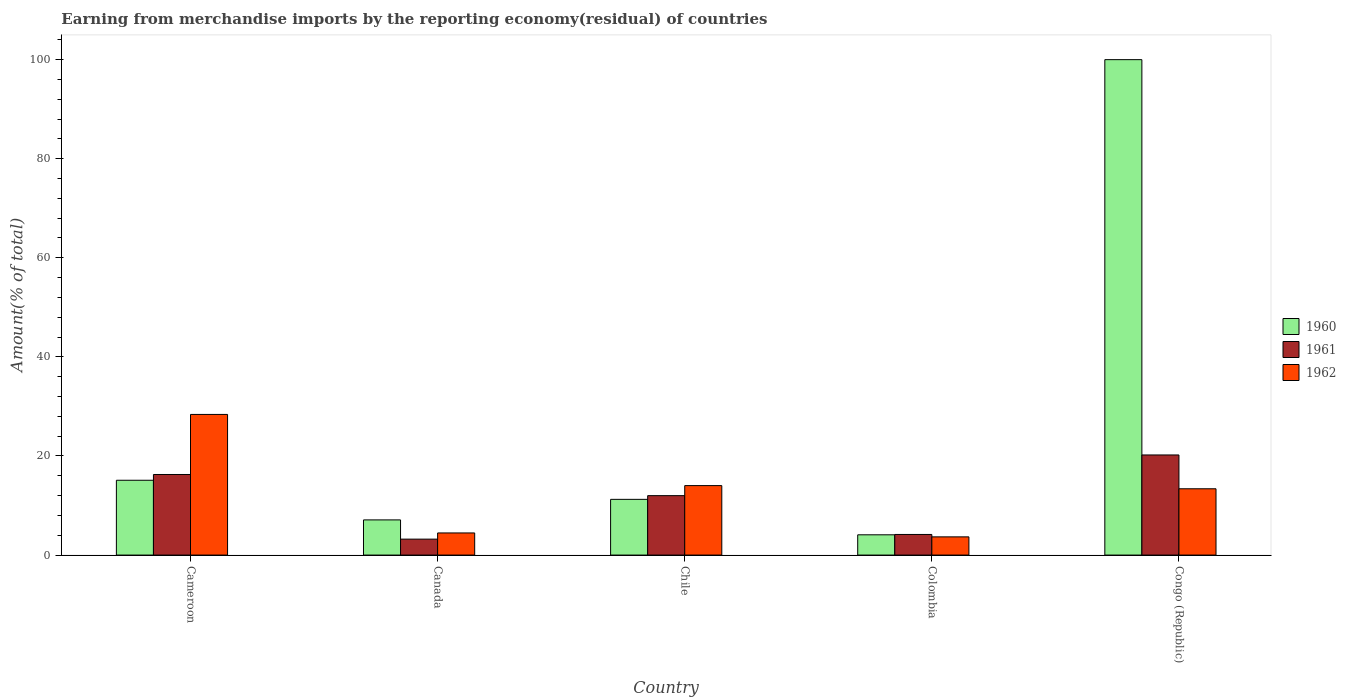What is the label of the 1st group of bars from the left?
Provide a short and direct response. Cameroon. What is the percentage of amount earned from merchandise imports in 1962 in Canada?
Make the answer very short. 4.47. Across all countries, what is the maximum percentage of amount earned from merchandise imports in 1960?
Offer a very short reply. 100. Across all countries, what is the minimum percentage of amount earned from merchandise imports in 1962?
Ensure brevity in your answer.  3.68. In which country was the percentage of amount earned from merchandise imports in 1962 maximum?
Your answer should be compact. Cameroon. In which country was the percentage of amount earned from merchandise imports in 1961 minimum?
Your response must be concise. Canada. What is the total percentage of amount earned from merchandise imports in 1962 in the graph?
Provide a short and direct response. 63.94. What is the difference between the percentage of amount earned from merchandise imports in 1961 in Cameroon and that in Congo (Republic)?
Provide a succinct answer. -3.94. What is the difference between the percentage of amount earned from merchandise imports in 1961 in Colombia and the percentage of amount earned from merchandise imports in 1960 in Canada?
Make the answer very short. -2.94. What is the average percentage of amount earned from merchandise imports in 1960 per country?
Offer a terse response. 27.51. What is the difference between the percentage of amount earned from merchandise imports of/in 1962 and percentage of amount earned from merchandise imports of/in 1961 in Canada?
Keep it short and to the point. 1.25. In how many countries, is the percentage of amount earned from merchandise imports in 1962 greater than 68 %?
Offer a very short reply. 0. What is the ratio of the percentage of amount earned from merchandise imports in 1961 in Canada to that in Colombia?
Offer a very short reply. 0.77. Is the percentage of amount earned from merchandise imports in 1961 in Colombia less than that in Congo (Republic)?
Offer a terse response. Yes. Is the difference between the percentage of amount earned from merchandise imports in 1962 in Canada and Chile greater than the difference between the percentage of amount earned from merchandise imports in 1961 in Canada and Chile?
Make the answer very short. No. What is the difference between the highest and the second highest percentage of amount earned from merchandise imports in 1960?
Provide a succinct answer. -88.75. What is the difference between the highest and the lowest percentage of amount earned from merchandise imports in 1960?
Your response must be concise. 95.91. What does the 1st bar from the right in Colombia represents?
Provide a succinct answer. 1962. Is it the case that in every country, the sum of the percentage of amount earned from merchandise imports in 1961 and percentage of amount earned from merchandise imports in 1960 is greater than the percentage of amount earned from merchandise imports in 1962?
Your response must be concise. Yes. Are all the bars in the graph horizontal?
Give a very brief answer. No. How many countries are there in the graph?
Provide a succinct answer. 5. What is the difference between two consecutive major ticks on the Y-axis?
Give a very brief answer. 20. Are the values on the major ticks of Y-axis written in scientific E-notation?
Offer a terse response. No. How many legend labels are there?
Give a very brief answer. 3. What is the title of the graph?
Provide a short and direct response. Earning from merchandise imports by the reporting economy(residual) of countries. What is the label or title of the X-axis?
Your response must be concise. Country. What is the label or title of the Y-axis?
Your answer should be very brief. Amount(% of total). What is the Amount(% of total) in 1960 in Cameroon?
Ensure brevity in your answer.  15.1. What is the Amount(% of total) of 1961 in Cameroon?
Keep it short and to the point. 16.26. What is the Amount(% of total) in 1962 in Cameroon?
Your response must be concise. 28.39. What is the Amount(% of total) of 1960 in Canada?
Your answer should be compact. 7.1. What is the Amount(% of total) of 1961 in Canada?
Your answer should be very brief. 3.22. What is the Amount(% of total) in 1962 in Canada?
Make the answer very short. 4.47. What is the Amount(% of total) of 1960 in Chile?
Offer a very short reply. 11.25. What is the Amount(% of total) of 1961 in Chile?
Offer a very short reply. 12. What is the Amount(% of total) of 1962 in Chile?
Your answer should be compact. 14.02. What is the Amount(% of total) in 1960 in Colombia?
Provide a succinct answer. 4.09. What is the Amount(% of total) of 1961 in Colombia?
Your answer should be very brief. 4.16. What is the Amount(% of total) in 1962 in Colombia?
Offer a very short reply. 3.68. What is the Amount(% of total) in 1960 in Congo (Republic)?
Your answer should be very brief. 100. What is the Amount(% of total) of 1961 in Congo (Republic)?
Provide a succinct answer. 20.21. What is the Amount(% of total) in 1962 in Congo (Republic)?
Offer a very short reply. 13.38. Across all countries, what is the maximum Amount(% of total) of 1961?
Give a very brief answer. 20.21. Across all countries, what is the maximum Amount(% of total) of 1962?
Provide a short and direct response. 28.39. Across all countries, what is the minimum Amount(% of total) in 1960?
Provide a succinct answer. 4.09. Across all countries, what is the minimum Amount(% of total) in 1961?
Make the answer very short. 3.22. Across all countries, what is the minimum Amount(% of total) of 1962?
Your answer should be very brief. 3.68. What is the total Amount(% of total) in 1960 in the graph?
Your answer should be compact. 137.54. What is the total Amount(% of total) in 1961 in the graph?
Your answer should be compact. 55.84. What is the total Amount(% of total) of 1962 in the graph?
Your response must be concise. 63.94. What is the difference between the Amount(% of total) of 1960 in Cameroon and that in Canada?
Give a very brief answer. 8. What is the difference between the Amount(% of total) in 1961 in Cameroon and that in Canada?
Give a very brief answer. 13.05. What is the difference between the Amount(% of total) of 1962 in Cameroon and that in Canada?
Provide a succinct answer. 23.92. What is the difference between the Amount(% of total) of 1960 in Cameroon and that in Chile?
Your answer should be compact. 3.85. What is the difference between the Amount(% of total) in 1961 in Cameroon and that in Chile?
Offer a very short reply. 4.27. What is the difference between the Amount(% of total) in 1962 in Cameroon and that in Chile?
Provide a succinct answer. 14.37. What is the difference between the Amount(% of total) of 1960 in Cameroon and that in Colombia?
Your response must be concise. 11.01. What is the difference between the Amount(% of total) of 1961 in Cameroon and that in Colombia?
Ensure brevity in your answer.  12.11. What is the difference between the Amount(% of total) in 1962 in Cameroon and that in Colombia?
Provide a short and direct response. 24.71. What is the difference between the Amount(% of total) of 1960 in Cameroon and that in Congo (Republic)?
Provide a short and direct response. -84.9. What is the difference between the Amount(% of total) in 1961 in Cameroon and that in Congo (Republic)?
Make the answer very short. -3.94. What is the difference between the Amount(% of total) in 1962 in Cameroon and that in Congo (Republic)?
Make the answer very short. 15.01. What is the difference between the Amount(% of total) of 1960 in Canada and that in Chile?
Offer a terse response. -4.15. What is the difference between the Amount(% of total) in 1961 in Canada and that in Chile?
Offer a very short reply. -8.78. What is the difference between the Amount(% of total) in 1962 in Canada and that in Chile?
Ensure brevity in your answer.  -9.56. What is the difference between the Amount(% of total) of 1960 in Canada and that in Colombia?
Provide a short and direct response. 3.01. What is the difference between the Amount(% of total) in 1961 in Canada and that in Colombia?
Your answer should be very brief. -0.94. What is the difference between the Amount(% of total) in 1962 in Canada and that in Colombia?
Provide a short and direct response. 0.79. What is the difference between the Amount(% of total) in 1960 in Canada and that in Congo (Republic)?
Your answer should be very brief. -92.9. What is the difference between the Amount(% of total) in 1961 in Canada and that in Congo (Republic)?
Provide a succinct answer. -16.99. What is the difference between the Amount(% of total) in 1962 in Canada and that in Congo (Republic)?
Keep it short and to the point. -8.92. What is the difference between the Amount(% of total) of 1960 in Chile and that in Colombia?
Your response must be concise. 7.16. What is the difference between the Amount(% of total) of 1961 in Chile and that in Colombia?
Your answer should be compact. 7.84. What is the difference between the Amount(% of total) of 1962 in Chile and that in Colombia?
Your answer should be very brief. 10.35. What is the difference between the Amount(% of total) in 1960 in Chile and that in Congo (Republic)?
Ensure brevity in your answer.  -88.75. What is the difference between the Amount(% of total) in 1961 in Chile and that in Congo (Republic)?
Your answer should be very brief. -8.21. What is the difference between the Amount(% of total) of 1962 in Chile and that in Congo (Republic)?
Provide a succinct answer. 0.64. What is the difference between the Amount(% of total) in 1960 in Colombia and that in Congo (Republic)?
Provide a short and direct response. -95.91. What is the difference between the Amount(% of total) of 1961 in Colombia and that in Congo (Republic)?
Provide a succinct answer. -16.05. What is the difference between the Amount(% of total) in 1962 in Colombia and that in Congo (Republic)?
Offer a very short reply. -9.71. What is the difference between the Amount(% of total) of 1960 in Cameroon and the Amount(% of total) of 1961 in Canada?
Ensure brevity in your answer.  11.88. What is the difference between the Amount(% of total) of 1960 in Cameroon and the Amount(% of total) of 1962 in Canada?
Provide a succinct answer. 10.64. What is the difference between the Amount(% of total) of 1961 in Cameroon and the Amount(% of total) of 1962 in Canada?
Provide a succinct answer. 11.8. What is the difference between the Amount(% of total) of 1960 in Cameroon and the Amount(% of total) of 1961 in Chile?
Provide a succinct answer. 3.11. What is the difference between the Amount(% of total) of 1960 in Cameroon and the Amount(% of total) of 1962 in Chile?
Your response must be concise. 1.08. What is the difference between the Amount(% of total) in 1961 in Cameroon and the Amount(% of total) in 1962 in Chile?
Your response must be concise. 2.24. What is the difference between the Amount(% of total) of 1960 in Cameroon and the Amount(% of total) of 1961 in Colombia?
Your response must be concise. 10.94. What is the difference between the Amount(% of total) of 1960 in Cameroon and the Amount(% of total) of 1962 in Colombia?
Provide a short and direct response. 11.43. What is the difference between the Amount(% of total) in 1961 in Cameroon and the Amount(% of total) in 1962 in Colombia?
Your answer should be compact. 12.59. What is the difference between the Amount(% of total) in 1960 in Cameroon and the Amount(% of total) in 1961 in Congo (Republic)?
Your answer should be very brief. -5.11. What is the difference between the Amount(% of total) of 1960 in Cameroon and the Amount(% of total) of 1962 in Congo (Republic)?
Your answer should be compact. 1.72. What is the difference between the Amount(% of total) of 1961 in Cameroon and the Amount(% of total) of 1962 in Congo (Republic)?
Give a very brief answer. 2.88. What is the difference between the Amount(% of total) of 1960 in Canada and the Amount(% of total) of 1961 in Chile?
Offer a very short reply. -4.9. What is the difference between the Amount(% of total) in 1960 in Canada and the Amount(% of total) in 1962 in Chile?
Keep it short and to the point. -6.92. What is the difference between the Amount(% of total) in 1961 in Canada and the Amount(% of total) in 1962 in Chile?
Your answer should be very brief. -10.81. What is the difference between the Amount(% of total) of 1960 in Canada and the Amount(% of total) of 1961 in Colombia?
Keep it short and to the point. 2.94. What is the difference between the Amount(% of total) in 1960 in Canada and the Amount(% of total) in 1962 in Colombia?
Make the answer very short. 3.42. What is the difference between the Amount(% of total) of 1961 in Canada and the Amount(% of total) of 1962 in Colombia?
Give a very brief answer. -0.46. What is the difference between the Amount(% of total) in 1960 in Canada and the Amount(% of total) in 1961 in Congo (Republic)?
Your answer should be very brief. -13.11. What is the difference between the Amount(% of total) of 1960 in Canada and the Amount(% of total) of 1962 in Congo (Republic)?
Provide a short and direct response. -6.28. What is the difference between the Amount(% of total) of 1961 in Canada and the Amount(% of total) of 1962 in Congo (Republic)?
Your response must be concise. -10.17. What is the difference between the Amount(% of total) in 1960 in Chile and the Amount(% of total) in 1961 in Colombia?
Your response must be concise. 7.09. What is the difference between the Amount(% of total) of 1960 in Chile and the Amount(% of total) of 1962 in Colombia?
Offer a very short reply. 7.57. What is the difference between the Amount(% of total) of 1961 in Chile and the Amount(% of total) of 1962 in Colombia?
Your answer should be very brief. 8.32. What is the difference between the Amount(% of total) in 1960 in Chile and the Amount(% of total) in 1961 in Congo (Republic)?
Offer a terse response. -8.96. What is the difference between the Amount(% of total) in 1960 in Chile and the Amount(% of total) in 1962 in Congo (Republic)?
Ensure brevity in your answer.  -2.14. What is the difference between the Amount(% of total) of 1961 in Chile and the Amount(% of total) of 1962 in Congo (Republic)?
Your response must be concise. -1.39. What is the difference between the Amount(% of total) in 1960 in Colombia and the Amount(% of total) in 1961 in Congo (Republic)?
Your answer should be very brief. -16.12. What is the difference between the Amount(% of total) in 1960 in Colombia and the Amount(% of total) in 1962 in Congo (Republic)?
Keep it short and to the point. -9.29. What is the difference between the Amount(% of total) of 1961 in Colombia and the Amount(% of total) of 1962 in Congo (Republic)?
Your answer should be compact. -9.22. What is the average Amount(% of total) of 1960 per country?
Your answer should be compact. 27.51. What is the average Amount(% of total) of 1961 per country?
Make the answer very short. 11.17. What is the average Amount(% of total) in 1962 per country?
Your response must be concise. 12.79. What is the difference between the Amount(% of total) of 1960 and Amount(% of total) of 1961 in Cameroon?
Give a very brief answer. -1.16. What is the difference between the Amount(% of total) in 1960 and Amount(% of total) in 1962 in Cameroon?
Offer a very short reply. -13.29. What is the difference between the Amount(% of total) of 1961 and Amount(% of total) of 1962 in Cameroon?
Provide a succinct answer. -12.12. What is the difference between the Amount(% of total) of 1960 and Amount(% of total) of 1961 in Canada?
Your answer should be compact. 3.88. What is the difference between the Amount(% of total) of 1960 and Amount(% of total) of 1962 in Canada?
Your answer should be compact. 2.63. What is the difference between the Amount(% of total) in 1961 and Amount(% of total) in 1962 in Canada?
Provide a short and direct response. -1.25. What is the difference between the Amount(% of total) of 1960 and Amount(% of total) of 1961 in Chile?
Your answer should be very brief. -0.75. What is the difference between the Amount(% of total) of 1960 and Amount(% of total) of 1962 in Chile?
Provide a succinct answer. -2.78. What is the difference between the Amount(% of total) in 1961 and Amount(% of total) in 1962 in Chile?
Your answer should be very brief. -2.03. What is the difference between the Amount(% of total) of 1960 and Amount(% of total) of 1961 in Colombia?
Offer a terse response. -0.07. What is the difference between the Amount(% of total) of 1960 and Amount(% of total) of 1962 in Colombia?
Keep it short and to the point. 0.41. What is the difference between the Amount(% of total) in 1961 and Amount(% of total) in 1962 in Colombia?
Give a very brief answer. 0.48. What is the difference between the Amount(% of total) in 1960 and Amount(% of total) in 1961 in Congo (Republic)?
Keep it short and to the point. 79.79. What is the difference between the Amount(% of total) of 1960 and Amount(% of total) of 1962 in Congo (Republic)?
Your response must be concise. 86.62. What is the difference between the Amount(% of total) in 1961 and Amount(% of total) in 1962 in Congo (Republic)?
Provide a short and direct response. 6.83. What is the ratio of the Amount(% of total) of 1960 in Cameroon to that in Canada?
Make the answer very short. 2.13. What is the ratio of the Amount(% of total) in 1961 in Cameroon to that in Canada?
Your response must be concise. 5.06. What is the ratio of the Amount(% of total) in 1962 in Cameroon to that in Canada?
Provide a succinct answer. 6.36. What is the ratio of the Amount(% of total) in 1960 in Cameroon to that in Chile?
Your answer should be compact. 1.34. What is the ratio of the Amount(% of total) in 1961 in Cameroon to that in Chile?
Your answer should be very brief. 1.36. What is the ratio of the Amount(% of total) in 1962 in Cameroon to that in Chile?
Your response must be concise. 2.02. What is the ratio of the Amount(% of total) in 1960 in Cameroon to that in Colombia?
Offer a very short reply. 3.69. What is the ratio of the Amount(% of total) of 1961 in Cameroon to that in Colombia?
Give a very brief answer. 3.91. What is the ratio of the Amount(% of total) in 1962 in Cameroon to that in Colombia?
Ensure brevity in your answer.  7.72. What is the ratio of the Amount(% of total) of 1960 in Cameroon to that in Congo (Republic)?
Offer a terse response. 0.15. What is the ratio of the Amount(% of total) of 1961 in Cameroon to that in Congo (Republic)?
Provide a short and direct response. 0.8. What is the ratio of the Amount(% of total) in 1962 in Cameroon to that in Congo (Republic)?
Your answer should be compact. 2.12. What is the ratio of the Amount(% of total) of 1960 in Canada to that in Chile?
Provide a short and direct response. 0.63. What is the ratio of the Amount(% of total) in 1961 in Canada to that in Chile?
Your answer should be very brief. 0.27. What is the ratio of the Amount(% of total) of 1962 in Canada to that in Chile?
Provide a succinct answer. 0.32. What is the ratio of the Amount(% of total) in 1960 in Canada to that in Colombia?
Offer a terse response. 1.74. What is the ratio of the Amount(% of total) in 1961 in Canada to that in Colombia?
Give a very brief answer. 0.77. What is the ratio of the Amount(% of total) of 1962 in Canada to that in Colombia?
Offer a very short reply. 1.22. What is the ratio of the Amount(% of total) of 1960 in Canada to that in Congo (Republic)?
Provide a short and direct response. 0.07. What is the ratio of the Amount(% of total) in 1961 in Canada to that in Congo (Republic)?
Keep it short and to the point. 0.16. What is the ratio of the Amount(% of total) in 1962 in Canada to that in Congo (Republic)?
Offer a terse response. 0.33. What is the ratio of the Amount(% of total) of 1960 in Chile to that in Colombia?
Ensure brevity in your answer.  2.75. What is the ratio of the Amount(% of total) in 1961 in Chile to that in Colombia?
Provide a short and direct response. 2.88. What is the ratio of the Amount(% of total) of 1962 in Chile to that in Colombia?
Provide a succinct answer. 3.82. What is the ratio of the Amount(% of total) of 1960 in Chile to that in Congo (Republic)?
Give a very brief answer. 0.11. What is the ratio of the Amount(% of total) in 1961 in Chile to that in Congo (Republic)?
Offer a terse response. 0.59. What is the ratio of the Amount(% of total) of 1962 in Chile to that in Congo (Republic)?
Keep it short and to the point. 1.05. What is the ratio of the Amount(% of total) of 1960 in Colombia to that in Congo (Republic)?
Provide a succinct answer. 0.04. What is the ratio of the Amount(% of total) of 1961 in Colombia to that in Congo (Republic)?
Ensure brevity in your answer.  0.21. What is the ratio of the Amount(% of total) in 1962 in Colombia to that in Congo (Republic)?
Keep it short and to the point. 0.27. What is the difference between the highest and the second highest Amount(% of total) in 1960?
Your answer should be very brief. 84.9. What is the difference between the highest and the second highest Amount(% of total) in 1961?
Provide a succinct answer. 3.94. What is the difference between the highest and the second highest Amount(% of total) of 1962?
Provide a short and direct response. 14.37. What is the difference between the highest and the lowest Amount(% of total) in 1960?
Ensure brevity in your answer.  95.91. What is the difference between the highest and the lowest Amount(% of total) in 1961?
Ensure brevity in your answer.  16.99. What is the difference between the highest and the lowest Amount(% of total) in 1962?
Your answer should be compact. 24.71. 